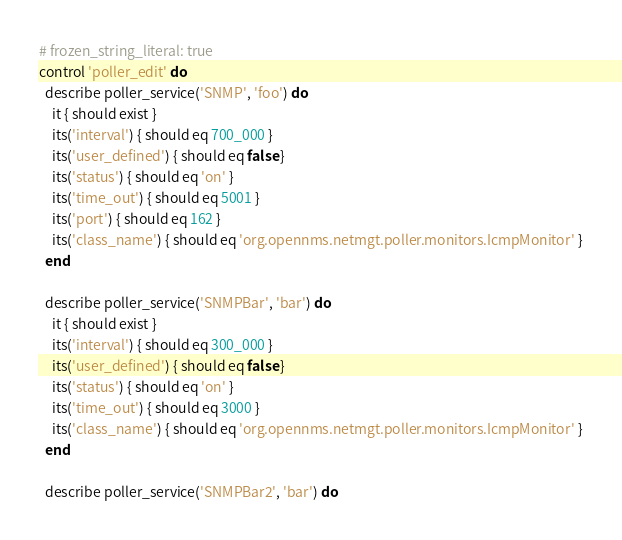Convert code to text. <code><loc_0><loc_0><loc_500><loc_500><_Ruby_># frozen_string_literal: true
control 'poller_edit' do
  describe poller_service('SNMP', 'foo') do
    it { should exist }
    its('interval') { should eq 700_000 }
    its('user_defined') { should eq false }
    its('status') { should eq 'on' }
    its('time_out') { should eq 5001 }
    its('port') { should eq 162 }
    its('class_name') { should eq 'org.opennms.netmgt.poller.monitors.IcmpMonitor' }
  end

  describe poller_service('SNMPBar', 'bar') do
    it { should exist }
    its('interval') { should eq 300_000 }
    its('user_defined') { should eq false }
    its('status') { should eq 'on' }
    its('time_out') { should eq 3000 }
    its('class_name') { should eq 'org.opennms.netmgt.poller.monitors.IcmpMonitor' }
  end

  describe poller_service('SNMPBar2', 'bar') do</code> 